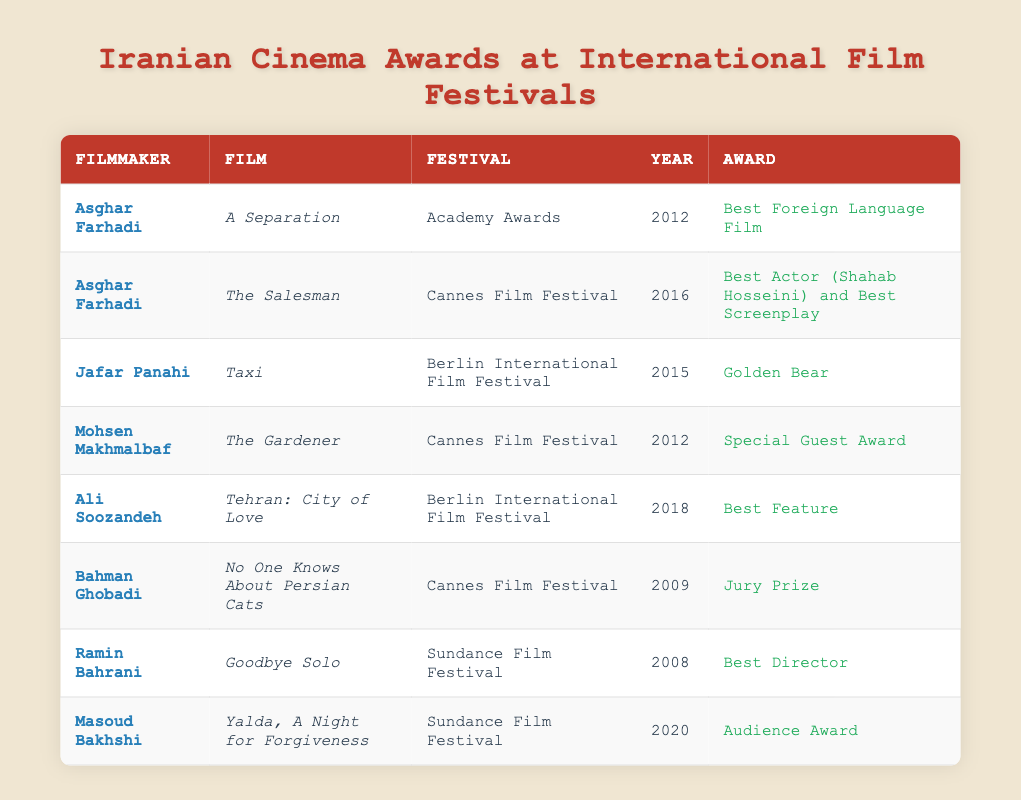What is the award won by Asghar Farhadi for the film "A Separation"? According to the table, Asghar Farhadi won the "Best Foreign Language Film" award for his film "A Separation" at the Academy Awards in 2012.
Answer: Best Foreign Language Film How many awards were won by Jafar Panahi? The table shows that Jafar Panahi won one award, which is the "Golden Bear" for his film "Taxi" at the Berlin International Film Festival in 2015.
Answer: One Which film received the Audience Award at the Sundance Film Festival? The film "Yalda, A Night for Forgiveness" directed by Masoud Bakhshi is noted in the table as receiving the "Audience Award" at the Sundance Film Festival in 2020.
Answer: Yalda, A Night for Forgiveness How many awards did filmmakers at the Cannes Film Festival win? Looking at the table, there are a total of four entries related to Cannes Film Festival: Asghar Farhadi’s "The Salesman," Mohsen Makhmalbaf’s "The Gardener," and Bahman Ghobadi’s "No One Knows About Persian Cats." Therefore, a total of three different films received awards at Cannes Film Festival.
Answer: Three Did Ali Soozandeh win an award for a film presented at the Berlin International Film Festival? Yes, according to the table, Ali Soozandeh won the "Best Feature" award for his film "Tehran: City of Love" at the Berlin International Film Festival in 2018.
Answer: Yes Which filmmaker has won the most awards according to this table? In the table, Asghar Farhadi appears twice, winning two separate awards for different films. The other filmmakers listed have one award each. Thus, Asghar Farhadi has won the most awards with two.
Answer: Asghar Farhadi What was the award received by Mohsen Makhmalbaf in 2012? The table states that Mohsen Makhmalbaf received the "Special Guest Award" for his film "The Gardener" at the Cannes Film Festival in 2012.
Answer: Special Guest Award Which filmmaker’s work is recognized at Sundance Film Festival in 2020? The filmmaker recognized at the Sundance Film Festival in 2020 is Masoud Bakhshi, who won the "Audience Award" for the film "Yalda, A Night for Forgiveness."
Answer: Masoud Bakhshi 